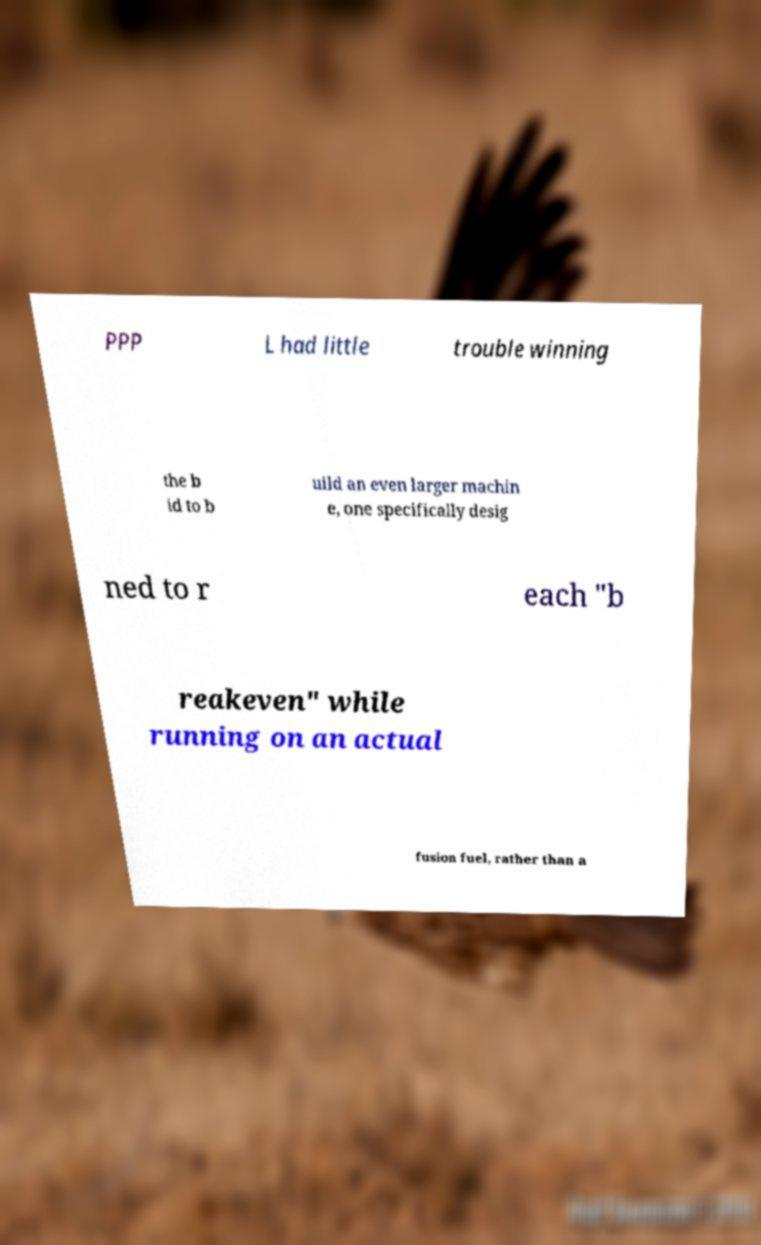For documentation purposes, I need the text within this image transcribed. Could you provide that? PPP L had little trouble winning the b id to b uild an even larger machin e, one specifically desig ned to r each "b reakeven" while running on an actual fusion fuel, rather than a 